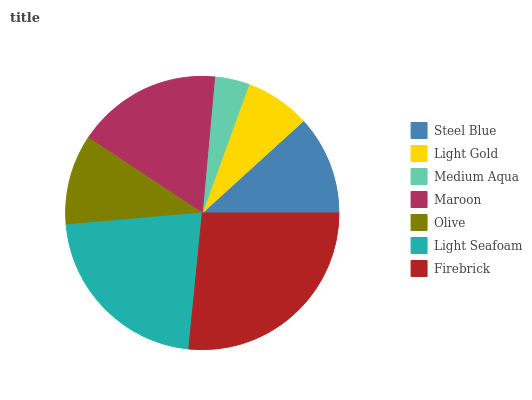Is Medium Aqua the minimum?
Answer yes or no. Yes. Is Firebrick the maximum?
Answer yes or no. Yes. Is Light Gold the minimum?
Answer yes or no. No. Is Light Gold the maximum?
Answer yes or no. No. Is Steel Blue greater than Light Gold?
Answer yes or no. Yes. Is Light Gold less than Steel Blue?
Answer yes or no. Yes. Is Light Gold greater than Steel Blue?
Answer yes or no. No. Is Steel Blue less than Light Gold?
Answer yes or no. No. Is Steel Blue the high median?
Answer yes or no. Yes. Is Steel Blue the low median?
Answer yes or no. Yes. Is Olive the high median?
Answer yes or no. No. Is Light Gold the low median?
Answer yes or no. No. 